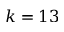<formula> <loc_0><loc_0><loc_500><loc_500>k = 1 3</formula> 